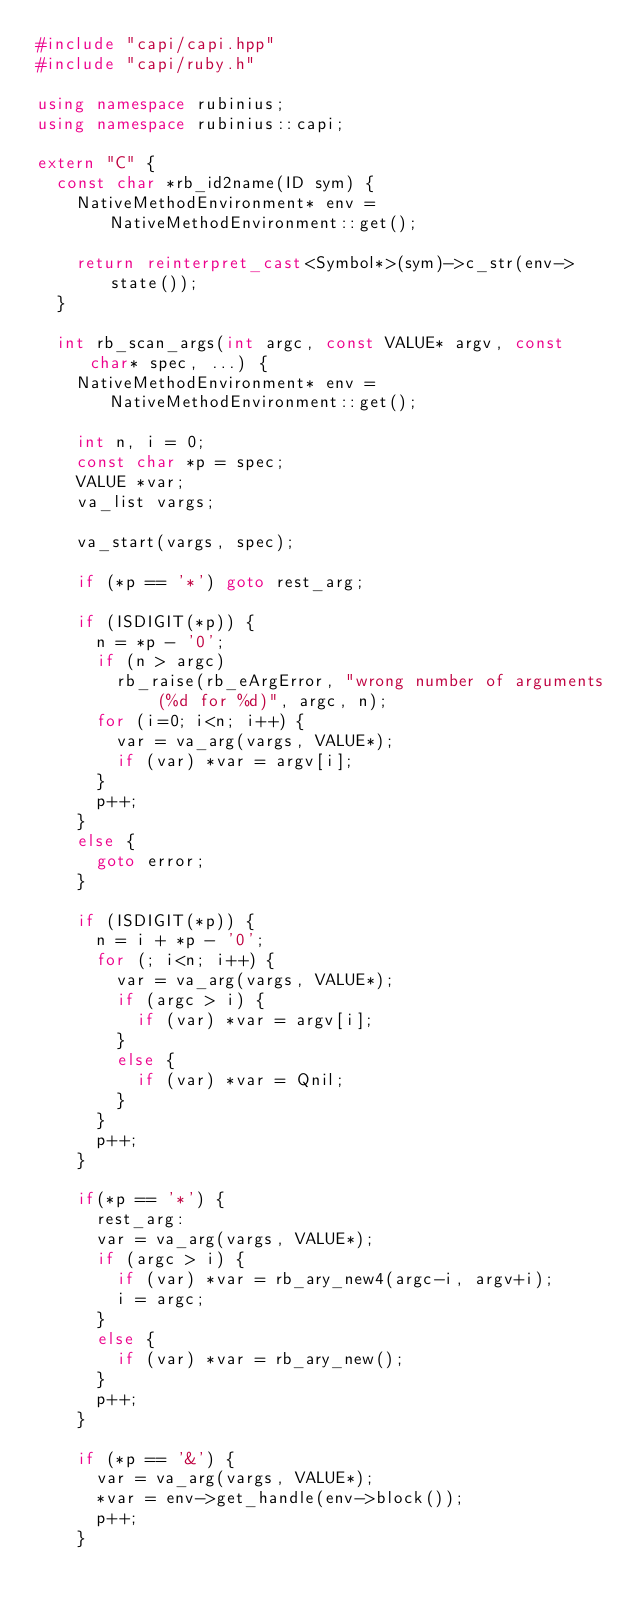<code> <loc_0><loc_0><loc_500><loc_500><_C++_>#include "capi/capi.hpp"
#include "capi/ruby.h"

using namespace rubinius;
using namespace rubinius::capi;

extern "C" {
  const char *rb_id2name(ID sym) {
    NativeMethodEnvironment* env = NativeMethodEnvironment::get();

    return reinterpret_cast<Symbol*>(sym)->c_str(env->state());
  }

  int rb_scan_args(int argc, const VALUE* argv, const char* spec, ...) {
    NativeMethodEnvironment* env = NativeMethodEnvironment::get();

    int n, i = 0;
    const char *p = spec;
    VALUE *var;
    va_list vargs;

    va_start(vargs, spec);

    if (*p == '*') goto rest_arg;

    if (ISDIGIT(*p)) {
      n = *p - '0';
      if (n > argc)
        rb_raise(rb_eArgError, "wrong number of arguments (%d for %d)", argc, n);
      for (i=0; i<n; i++) {
        var = va_arg(vargs, VALUE*);
        if (var) *var = argv[i];
      }
      p++;
    }
    else {
      goto error;
    }

    if (ISDIGIT(*p)) {
      n = i + *p - '0';
      for (; i<n; i++) {
        var = va_arg(vargs, VALUE*);
        if (argc > i) {
          if (var) *var = argv[i];
        }
        else {
          if (var) *var = Qnil;
        }
      }
      p++;
    }

    if(*p == '*') {
      rest_arg:
      var = va_arg(vargs, VALUE*);
      if (argc > i) {
        if (var) *var = rb_ary_new4(argc-i, argv+i);
        i = argc;
      }
      else {
        if (var) *var = rb_ary_new();
      }
      p++;
    }

    if (*p == '&') {
      var = va_arg(vargs, VALUE*);
      *var = env->get_handle(env->block());
      p++;
    }</code> 